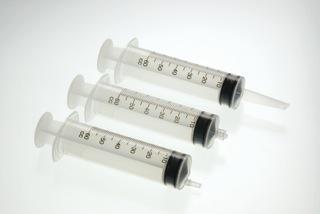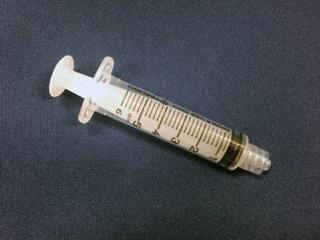The first image is the image on the left, the second image is the image on the right. For the images shown, is this caption "The right image shows a single syringe angled with its tip at the lower right." true? Answer yes or no. Yes. The first image is the image on the left, the second image is the image on the right. For the images displayed, is the sentence "The left image has at least six syringes" factually correct? Answer yes or no. No. 